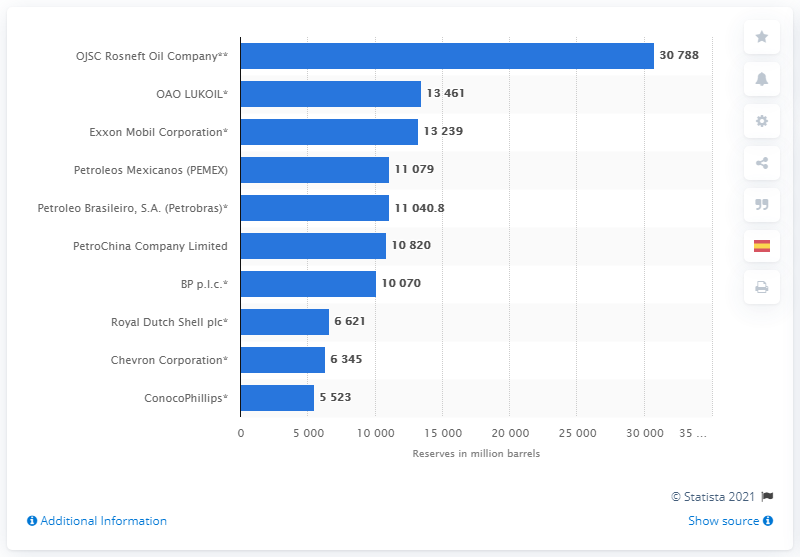Indicate a few pertinent items in this graphic. OAO LUKOIL had 13,461 barrels of oil in 2013. 